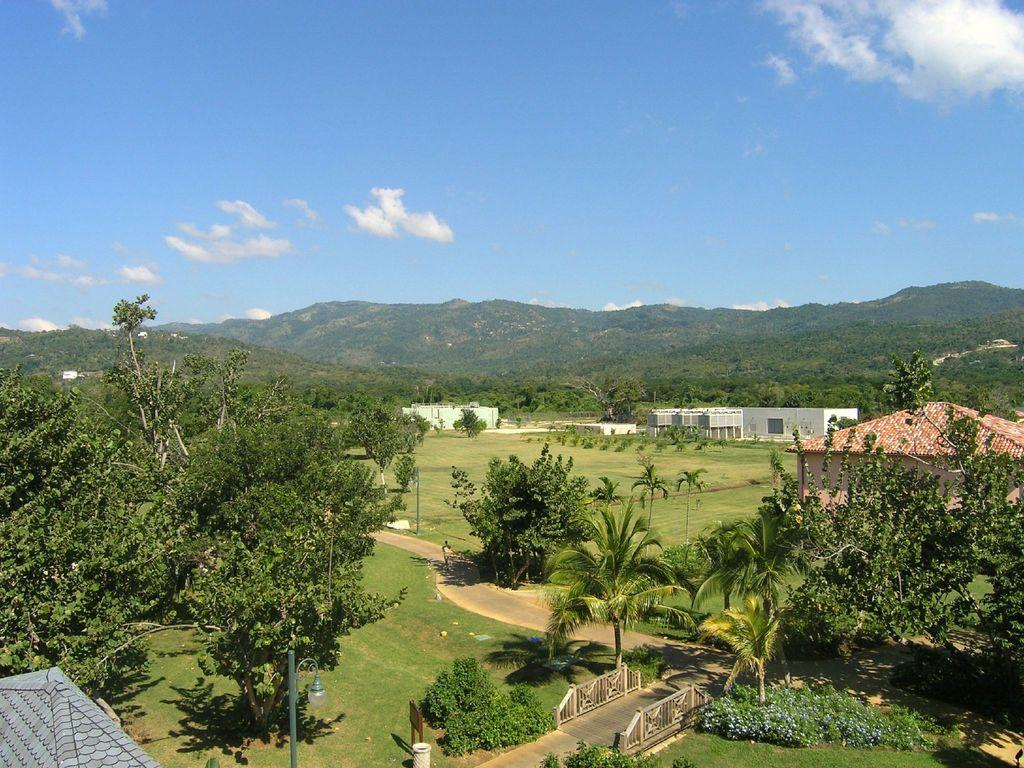What type of vegetation can be seen in the image? There are trees in the image. What color are the trees? The trees are green. What structure is visible in the background of the image? There is a house in the background of the image. What color is the house? The house is white. What is visible above the trees and the house in the image? The sky is visible in the image. What colors can be seen in the sky? The sky has blue and white colors. What type of pump is used to irrigate the trees in the image? There is no pump visible in the image, and it does not show any irrigation system for the trees. How many bags of rice can be seen on the ground near the trees in the image? There are no bags of rice present in the image. 